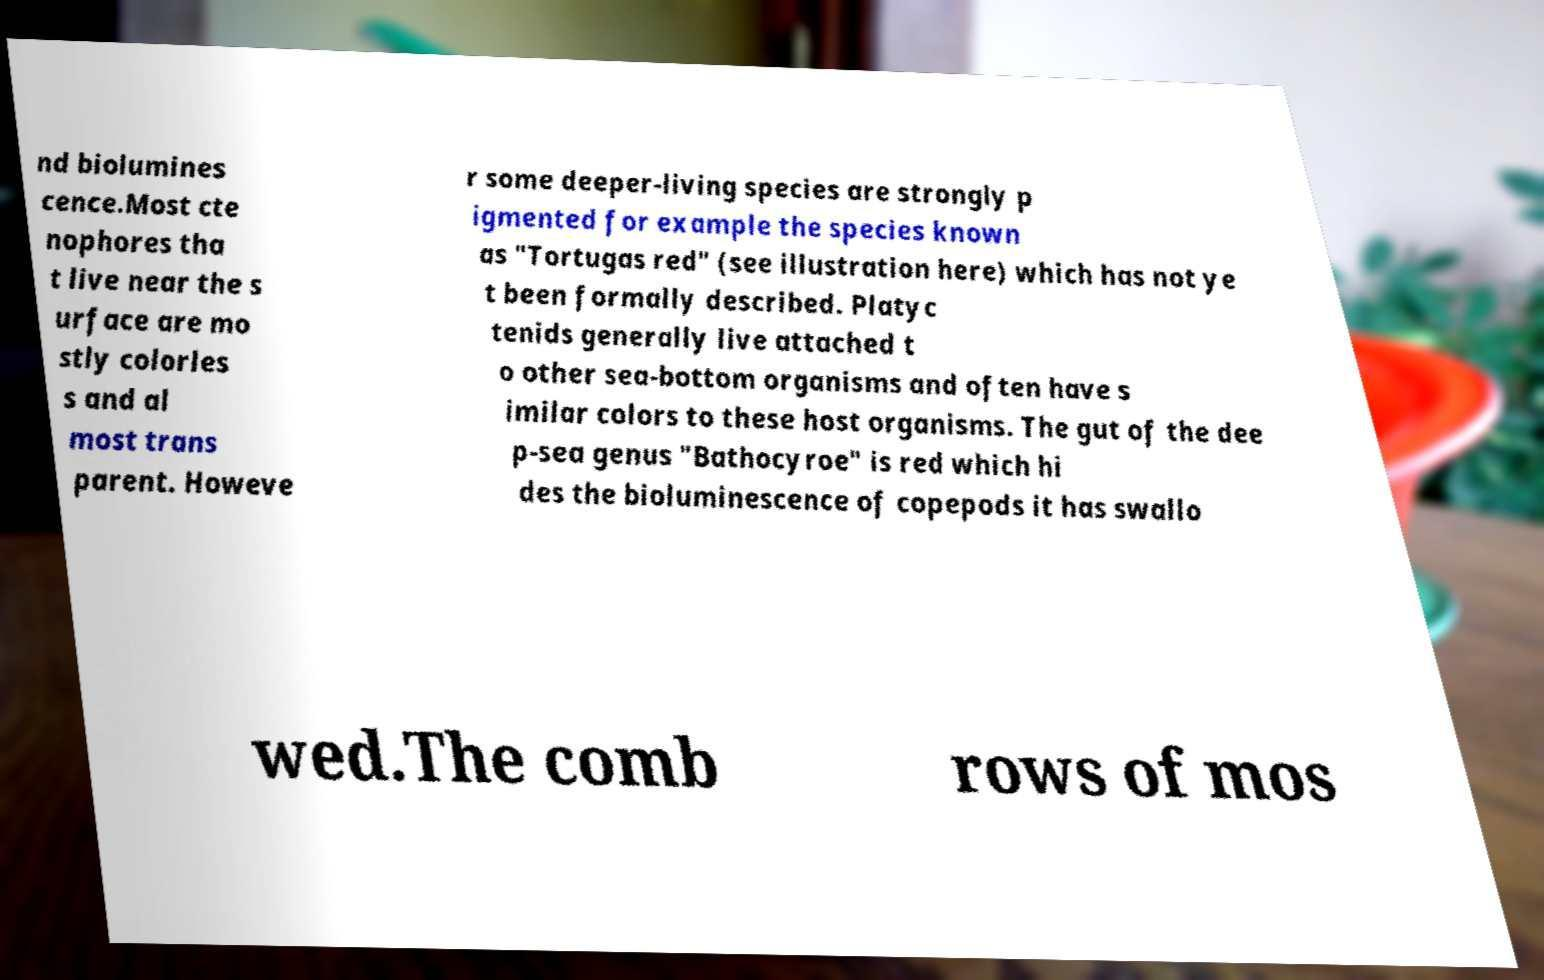Can you accurately transcribe the text from the provided image for me? nd biolumines cence.Most cte nophores tha t live near the s urface are mo stly colorles s and al most trans parent. Howeve r some deeper-living species are strongly p igmented for example the species known as "Tortugas red" (see illustration here) which has not ye t been formally described. Platyc tenids generally live attached t o other sea-bottom organisms and often have s imilar colors to these host organisms. The gut of the dee p-sea genus "Bathocyroe" is red which hi des the bioluminescence of copepods it has swallo wed.The comb rows of mos 